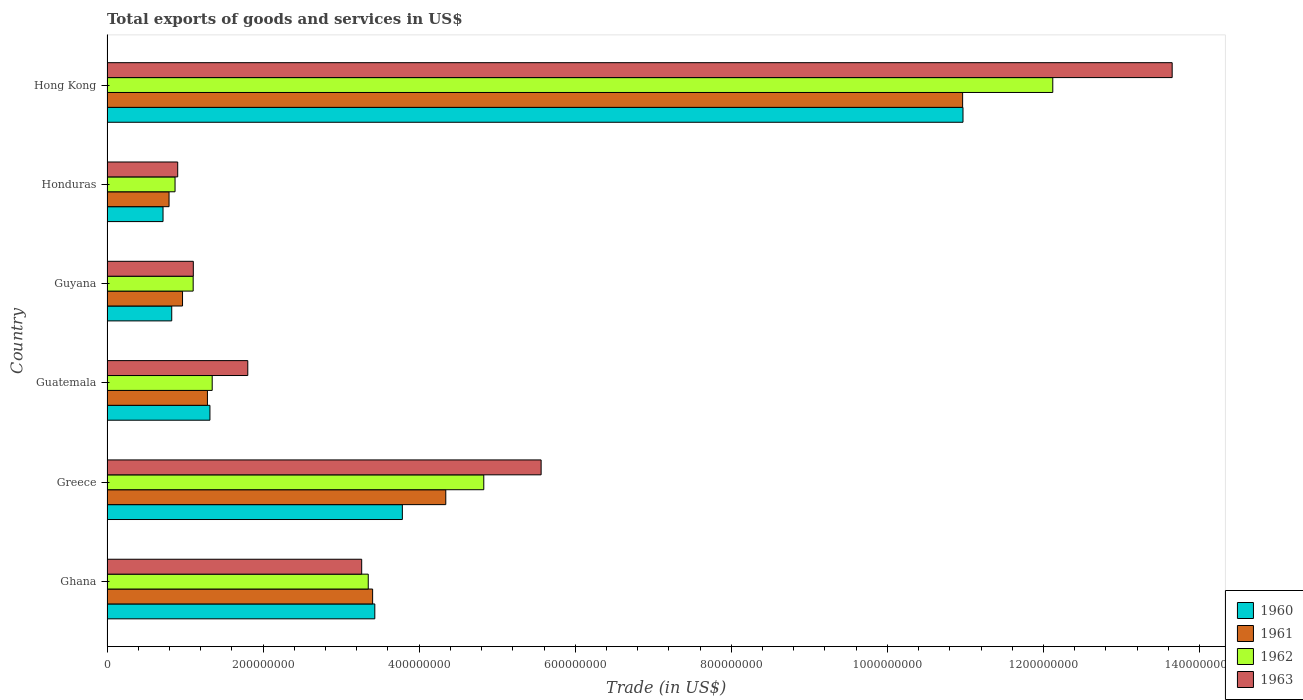How many different coloured bars are there?
Offer a terse response. 4. How many groups of bars are there?
Offer a very short reply. 6. Are the number of bars on each tick of the Y-axis equal?
Your answer should be very brief. Yes. What is the label of the 4th group of bars from the top?
Offer a terse response. Guatemala. In how many cases, is the number of bars for a given country not equal to the number of legend labels?
Give a very brief answer. 0. What is the total exports of goods and services in 1962 in Guatemala?
Keep it short and to the point. 1.35e+08. Across all countries, what is the maximum total exports of goods and services in 1962?
Make the answer very short. 1.21e+09. Across all countries, what is the minimum total exports of goods and services in 1962?
Offer a terse response. 8.72e+07. In which country was the total exports of goods and services in 1963 maximum?
Give a very brief answer. Hong Kong. In which country was the total exports of goods and services in 1961 minimum?
Provide a short and direct response. Honduras. What is the total total exports of goods and services in 1962 in the graph?
Give a very brief answer. 2.36e+09. What is the difference between the total exports of goods and services in 1961 in Greece and that in Honduras?
Provide a short and direct response. 3.55e+08. What is the difference between the total exports of goods and services in 1960 in Ghana and the total exports of goods and services in 1961 in Honduras?
Offer a terse response. 2.64e+08. What is the average total exports of goods and services in 1960 per country?
Provide a short and direct response. 3.51e+08. What is the difference between the total exports of goods and services in 1961 and total exports of goods and services in 1963 in Guatemala?
Provide a succinct answer. -5.17e+07. What is the ratio of the total exports of goods and services in 1963 in Ghana to that in Guyana?
Offer a very short reply. 2.95. What is the difference between the highest and the second highest total exports of goods and services in 1961?
Your response must be concise. 6.62e+08. What is the difference between the highest and the lowest total exports of goods and services in 1961?
Your response must be concise. 1.02e+09. In how many countries, is the total exports of goods and services in 1960 greater than the average total exports of goods and services in 1960 taken over all countries?
Provide a short and direct response. 2. Is it the case that in every country, the sum of the total exports of goods and services in 1960 and total exports of goods and services in 1963 is greater than the sum of total exports of goods and services in 1961 and total exports of goods and services in 1962?
Your answer should be compact. No. What does the 3rd bar from the top in Greece represents?
Ensure brevity in your answer.  1961. What does the 2nd bar from the bottom in Guatemala represents?
Offer a terse response. 1961. Is it the case that in every country, the sum of the total exports of goods and services in 1963 and total exports of goods and services in 1960 is greater than the total exports of goods and services in 1962?
Provide a succinct answer. Yes. Are all the bars in the graph horizontal?
Your answer should be very brief. Yes. How many countries are there in the graph?
Give a very brief answer. 6. Are the values on the major ticks of X-axis written in scientific E-notation?
Provide a succinct answer. No. Does the graph contain any zero values?
Your answer should be very brief. No. Where does the legend appear in the graph?
Your answer should be compact. Bottom right. How many legend labels are there?
Your response must be concise. 4. What is the title of the graph?
Offer a very short reply. Total exports of goods and services in US$. Does "1970" appear as one of the legend labels in the graph?
Provide a short and direct response. No. What is the label or title of the X-axis?
Offer a terse response. Trade (in US$). What is the label or title of the Y-axis?
Offer a very short reply. Country. What is the Trade (in US$) in 1960 in Ghana?
Provide a succinct answer. 3.43e+08. What is the Trade (in US$) of 1961 in Ghana?
Provide a short and direct response. 3.40e+08. What is the Trade (in US$) in 1962 in Ghana?
Keep it short and to the point. 3.35e+08. What is the Trade (in US$) in 1963 in Ghana?
Your answer should be compact. 3.26e+08. What is the Trade (in US$) of 1960 in Greece?
Your answer should be compact. 3.78e+08. What is the Trade (in US$) in 1961 in Greece?
Provide a short and direct response. 4.34e+08. What is the Trade (in US$) in 1962 in Greece?
Keep it short and to the point. 4.83e+08. What is the Trade (in US$) in 1963 in Greece?
Offer a very short reply. 5.56e+08. What is the Trade (in US$) in 1960 in Guatemala?
Your answer should be very brief. 1.32e+08. What is the Trade (in US$) in 1961 in Guatemala?
Ensure brevity in your answer.  1.29e+08. What is the Trade (in US$) of 1962 in Guatemala?
Keep it short and to the point. 1.35e+08. What is the Trade (in US$) in 1963 in Guatemala?
Keep it short and to the point. 1.80e+08. What is the Trade (in US$) in 1960 in Guyana?
Offer a very short reply. 8.29e+07. What is the Trade (in US$) in 1961 in Guyana?
Offer a very short reply. 9.68e+07. What is the Trade (in US$) of 1962 in Guyana?
Provide a succinct answer. 1.10e+08. What is the Trade (in US$) in 1963 in Guyana?
Your response must be concise. 1.11e+08. What is the Trade (in US$) in 1960 in Honduras?
Offer a very short reply. 7.18e+07. What is the Trade (in US$) of 1961 in Honduras?
Ensure brevity in your answer.  7.95e+07. What is the Trade (in US$) of 1962 in Honduras?
Offer a very short reply. 8.72e+07. What is the Trade (in US$) in 1963 in Honduras?
Ensure brevity in your answer.  9.06e+07. What is the Trade (in US$) in 1960 in Hong Kong?
Offer a terse response. 1.10e+09. What is the Trade (in US$) of 1961 in Hong Kong?
Provide a short and direct response. 1.10e+09. What is the Trade (in US$) in 1962 in Hong Kong?
Make the answer very short. 1.21e+09. What is the Trade (in US$) of 1963 in Hong Kong?
Ensure brevity in your answer.  1.36e+09. Across all countries, what is the maximum Trade (in US$) in 1960?
Keep it short and to the point. 1.10e+09. Across all countries, what is the maximum Trade (in US$) of 1961?
Keep it short and to the point. 1.10e+09. Across all countries, what is the maximum Trade (in US$) in 1962?
Provide a succinct answer. 1.21e+09. Across all countries, what is the maximum Trade (in US$) in 1963?
Provide a short and direct response. 1.36e+09. Across all countries, what is the minimum Trade (in US$) of 1960?
Offer a very short reply. 7.18e+07. Across all countries, what is the minimum Trade (in US$) in 1961?
Ensure brevity in your answer.  7.95e+07. Across all countries, what is the minimum Trade (in US$) in 1962?
Offer a terse response. 8.72e+07. Across all countries, what is the minimum Trade (in US$) of 1963?
Provide a succinct answer. 9.06e+07. What is the total Trade (in US$) in 1960 in the graph?
Make the answer very short. 2.11e+09. What is the total Trade (in US$) of 1961 in the graph?
Provide a succinct answer. 2.18e+09. What is the total Trade (in US$) of 1962 in the graph?
Offer a terse response. 2.36e+09. What is the total Trade (in US$) of 1963 in the graph?
Your answer should be compact. 2.63e+09. What is the difference between the Trade (in US$) in 1960 in Ghana and that in Greece?
Ensure brevity in your answer.  -3.53e+07. What is the difference between the Trade (in US$) of 1961 in Ghana and that in Greece?
Your response must be concise. -9.37e+07. What is the difference between the Trade (in US$) in 1962 in Ghana and that in Greece?
Provide a short and direct response. -1.48e+08. What is the difference between the Trade (in US$) in 1963 in Ghana and that in Greece?
Make the answer very short. -2.30e+08. What is the difference between the Trade (in US$) in 1960 in Ghana and that in Guatemala?
Ensure brevity in your answer.  2.11e+08. What is the difference between the Trade (in US$) of 1961 in Ghana and that in Guatemala?
Make the answer very short. 2.12e+08. What is the difference between the Trade (in US$) in 1962 in Ghana and that in Guatemala?
Give a very brief answer. 2.00e+08. What is the difference between the Trade (in US$) of 1963 in Ghana and that in Guatemala?
Ensure brevity in your answer.  1.46e+08. What is the difference between the Trade (in US$) of 1960 in Ghana and that in Guyana?
Keep it short and to the point. 2.60e+08. What is the difference between the Trade (in US$) in 1961 in Ghana and that in Guyana?
Offer a very short reply. 2.44e+08. What is the difference between the Trade (in US$) in 1962 in Ghana and that in Guyana?
Make the answer very short. 2.24e+08. What is the difference between the Trade (in US$) of 1963 in Ghana and that in Guyana?
Offer a terse response. 2.16e+08. What is the difference between the Trade (in US$) in 1960 in Ghana and that in Honduras?
Your answer should be very brief. 2.71e+08. What is the difference between the Trade (in US$) of 1961 in Ghana and that in Honduras?
Offer a very short reply. 2.61e+08. What is the difference between the Trade (in US$) of 1962 in Ghana and that in Honduras?
Offer a terse response. 2.48e+08. What is the difference between the Trade (in US$) in 1963 in Ghana and that in Honduras?
Provide a short and direct response. 2.36e+08. What is the difference between the Trade (in US$) of 1960 in Ghana and that in Hong Kong?
Provide a short and direct response. -7.54e+08. What is the difference between the Trade (in US$) in 1961 in Ghana and that in Hong Kong?
Your response must be concise. -7.56e+08. What is the difference between the Trade (in US$) of 1962 in Ghana and that in Hong Kong?
Your answer should be compact. -8.77e+08. What is the difference between the Trade (in US$) of 1963 in Ghana and that in Hong Kong?
Your answer should be compact. -1.04e+09. What is the difference between the Trade (in US$) of 1960 in Greece and that in Guatemala?
Your response must be concise. 2.47e+08. What is the difference between the Trade (in US$) in 1961 in Greece and that in Guatemala?
Ensure brevity in your answer.  3.05e+08. What is the difference between the Trade (in US$) in 1962 in Greece and that in Guatemala?
Keep it short and to the point. 3.48e+08. What is the difference between the Trade (in US$) in 1963 in Greece and that in Guatemala?
Make the answer very short. 3.76e+08. What is the difference between the Trade (in US$) in 1960 in Greece and that in Guyana?
Provide a short and direct response. 2.96e+08. What is the difference between the Trade (in US$) in 1961 in Greece and that in Guyana?
Provide a short and direct response. 3.37e+08. What is the difference between the Trade (in US$) in 1962 in Greece and that in Guyana?
Offer a terse response. 3.72e+08. What is the difference between the Trade (in US$) of 1963 in Greece and that in Guyana?
Make the answer very short. 4.46e+08. What is the difference between the Trade (in US$) in 1960 in Greece and that in Honduras?
Offer a terse response. 3.07e+08. What is the difference between the Trade (in US$) of 1961 in Greece and that in Honduras?
Provide a succinct answer. 3.55e+08. What is the difference between the Trade (in US$) of 1962 in Greece and that in Honduras?
Your answer should be compact. 3.96e+08. What is the difference between the Trade (in US$) in 1963 in Greece and that in Honduras?
Your response must be concise. 4.66e+08. What is the difference between the Trade (in US$) in 1960 in Greece and that in Hong Kong?
Your answer should be compact. -7.18e+08. What is the difference between the Trade (in US$) in 1961 in Greece and that in Hong Kong?
Provide a short and direct response. -6.62e+08. What is the difference between the Trade (in US$) in 1962 in Greece and that in Hong Kong?
Provide a succinct answer. -7.29e+08. What is the difference between the Trade (in US$) of 1963 in Greece and that in Hong Kong?
Your answer should be very brief. -8.09e+08. What is the difference between the Trade (in US$) of 1960 in Guatemala and that in Guyana?
Keep it short and to the point. 4.90e+07. What is the difference between the Trade (in US$) in 1961 in Guatemala and that in Guyana?
Make the answer very short. 3.19e+07. What is the difference between the Trade (in US$) of 1962 in Guatemala and that in Guyana?
Your response must be concise. 2.44e+07. What is the difference between the Trade (in US$) in 1963 in Guatemala and that in Guyana?
Offer a terse response. 6.98e+07. What is the difference between the Trade (in US$) in 1960 in Guatemala and that in Honduras?
Make the answer very short. 6.01e+07. What is the difference between the Trade (in US$) of 1961 in Guatemala and that in Honduras?
Offer a terse response. 4.92e+07. What is the difference between the Trade (in US$) in 1962 in Guatemala and that in Honduras?
Provide a short and direct response. 4.76e+07. What is the difference between the Trade (in US$) of 1963 in Guatemala and that in Honduras?
Your answer should be very brief. 8.98e+07. What is the difference between the Trade (in US$) of 1960 in Guatemala and that in Hong Kong?
Your response must be concise. -9.65e+08. What is the difference between the Trade (in US$) in 1961 in Guatemala and that in Hong Kong?
Keep it short and to the point. -9.68e+08. What is the difference between the Trade (in US$) of 1962 in Guatemala and that in Hong Kong?
Offer a terse response. -1.08e+09. What is the difference between the Trade (in US$) of 1963 in Guatemala and that in Hong Kong?
Offer a very short reply. -1.18e+09. What is the difference between the Trade (in US$) of 1960 in Guyana and that in Honduras?
Make the answer very short. 1.11e+07. What is the difference between the Trade (in US$) of 1961 in Guyana and that in Honduras?
Make the answer very short. 1.73e+07. What is the difference between the Trade (in US$) in 1962 in Guyana and that in Honduras?
Your answer should be compact. 2.32e+07. What is the difference between the Trade (in US$) in 1963 in Guyana and that in Honduras?
Your answer should be very brief. 2.00e+07. What is the difference between the Trade (in US$) of 1960 in Guyana and that in Hong Kong?
Your answer should be compact. -1.01e+09. What is the difference between the Trade (in US$) in 1961 in Guyana and that in Hong Kong?
Your response must be concise. -1.00e+09. What is the difference between the Trade (in US$) of 1962 in Guyana and that in Hong Kong?
Ensure brevity in your answer.  -1.10e+09. What is the difference between the Trade (in US$) in 1963 in Guyana and that in Hong Kong?
Your answer should be very brief. -1.25e+09. What is the difference between the Trade (in US$) of 1960 in Honduras and that in Hong Kong?
Keep it short and to the point. -1.03e+09. What is the difference between the Trade (in US$) in 1961 in Honduras and that in Hong Kong?
Your response must be concise. -1.02e+09. What is the difference between the Trade (in US$) in 1962 in Honduras and that in Hong Kong?
Ensure brevity in your answer.  -1.12e+09. What is the difference between the Trade (in US$) of 1963 in Honduras and that in Hong Kong?
Offer a terse response. -1.27e+09. What is the difference between the Trade (in US$) of 1960 in Ghana and the Trade (in US$) of 1961 in Greece?
Your answer should be very brief. -9.09e+07. What is the difference between the Trade (in US$) of 1960 in Ghana and the Trade (in US$) of 1962 in Greece?
Your answer should be very brief. -1.40e+08. What is the difference between the Trade (in US$) in 1960 in Ghana and the Trade (in US$) in 1963 in Greece?
Ensure brevity in your answer.  -2.13e+08. What is the difference between the Trade (in US$) of 1961 in Ghana and the Trade (in US$) of 1962 in Greece?
Make the answer very short. -1.42e+08. What is the difference between the Trade (in US$) in 1961 in Ghana and the Trade (in US$) in 1963 in Greece?
Offer a terse response. -2.16e+08. What is the difference between the Trade (in US$) of 1962 in Ghana and the Trade (in US$) of 1963 in Greece?
Your response must be concise. -2.22e+08. What is the difference between the Trade (in US$) of 1960 in Ghana and the Trade (in US$) of 1961 in Guatemala?
Make the answer very short. 2.14e+08. What is the difference between the Trade (in US$) of 1960 in Ghana and the Trade (in US$) of 1962 in Guatemala?
Provide a short and direct response. 2.08e+08. What is the difference between the Trade (in US$) in 1960 in Ghana and the Trade (in US$) in 1963 in Guatemala?
Offer a very short reply. 1.63e+08. What is the difference between the Trade (in US$) in 1961 in Ghana and the Trade (in US$) in 1962 in Guatemala?
Make the answer very short. 2.06e+08. What is the difference between the Trade (in US$) in 1961 in Ghana and the Trade (in US$) in 1963 in Guatemala?
Keep it short and to the point. 1.60e+08. What is the difference between the Trade (in US$) in 1962 in Ghana and the Trade (in US$) in 1963 in Guatemala?
Provide a succinct answer. 1.54e+08. What is the difference between the Trade (in US$) of 1960 in Ghana and the Trade (in US$) of 1961 in Guyana?
Your answer should be compact. 2.46e+08. What is the difference between the Trade (in US$) in 1960 in Ghana and the Trade (in US$) in 1962 in Guyana?
Provide a short and direct response. 2.33e+08. What is the difference between the Trade (in US$) in 1960 in Ghana and the Trade (in US$) in 1963 in Guyana?
Offer a terse response. 2.33e+08. What is the difference between the Trade (in US$) in 1961 in Ghana and the Trade (in US$) in 1962 in Guyana?
Keep it short and to the point. 2.30e+08. What is the difference between the Trade (in US$) of 1961 in Ghana and the Trade (in US$) of 1963 in Guyana?
Offer a very short reply. 2.30e+08. What is the difference between the Trade (in US$) of 1962 in Ghana and the Trade (in US$) of 1963 in Guyana?
Provide a succinct answer. 2.24e+08. What is the difference between the Trade (in US$) of 1960 in Ghana and the Trade (in US$) of 1961 in Honduras?
Offer a very short reply. 2.64e+08. What is the difference between the Trade (in US$) of 1960 in Ghana and the Trade (in US$) of 1962 in Honduras?
Offer a very short reply. 2.56e+08. What is the difference between the Trade (in US$) of 1960 in Ghana and the Trade (in US$) of 1963 in Honduras?
Your response must be concise. 2.53e+08. What is the difference between the Trade (in US$) in 1961 in Ghana and the Trade (in US$) in 1962 in Honduras?
Your response must be concise. 2.53e+08. What is the difference between the Trade (in US$) in 1961 in Ghana and the Trade (in US$) in 1963 in Honduras?
Your answer should be very brief. 2.50e+08. What is the difference between the Trade (in US$) of 1962 in Ghana and the Trade (in US$) of 1963 in Honduras?
Give a very brief answer. 2.44e+08. What is the difference between the Trade (in US$) of 1960 in Ghana and the Trade (in US$) of 1961 in Hong Kong?
Provide a succinct answer. -7.53e+08. What is the difference between the Trade (in US$) in 1960 in Ghana and the Trade (in US$) in 1962 in Hong Kong?
Provide a short and direct response. -8.69e+08. What is the difference between the Trade (in US$) of 1960 in Ghana and the Trade (in US$) of 1963 in Hong Kong?
Provide a succinct answer. -1.02e+09. What is the difference between the Trade (in US$) of 1961 in Ghana and the Trade (in US$) of 1962 in Hong Kong?
Your response must be concise. -8.72e+08. What is the difference between the Trade (in US$) of 1961 in Ghana and the Trade (in US$) of 1963 in Hong Kong?
Keep it short and to the point. -1.02e+09. What is the difference between the Trade (in US$) in 1962 in Ghana and the Trade (in US$) in 1963 in Hong Kong?
Ensure brevity in your answer.  -1.03e+09. What is the difference between the Trade (in US$) of 1960 in Greece and the Trade (in US$) of 1961 in Guatemala?
Provide a short and direct response. 2.50e+08. What is the difference between the Trade (in US$) in 1960 in Greece and the Trade (in US$) in 1962 in Guatemala?
Your answer should be very brief. 2.44e+08. What is the difference between the Trade (in US$) in 1960 in Greece and the Trade (in US$) in 1963 in Guatemala?
Your answer should be compact. 1.98e+08. What is the difference between the Trade (in US$) in 1961 in Greece and the Trade (in US$) in 1962 in Guatemala?
Keep it short and to the point. 2.99e+08. What is the difference between the Trade (in US$) of 1961 in Greece and the Trade (in US$) of 1963 in Guatemala?
Offer a very short reply. 2.54e+08. What is the difference between the Trade (in US$) in 1962 in Greece and the Trade (in US$) in 1963 in Guatemala?
Ensure brevity in your answer.  3.02e+08. What is the difference between the Trade (in US$) in 1960 in Greece and the Trade (in US$) in 1961 in Guyana?
Your answer should be compact. 2.82e+08. What is the difference between the Trade (in US$) of 1960 in Greece and the Trade (in US$) of 1962 in Guyana?
Give a very brief answer. 2.68e+08. What is the difference between the Trade (in US$) in 1960 in Greece and the Trade (in US$) in 1963 in Guyana?
Offer a terse response. 2.68e+08. What is the difference between the Trade (in US$) of 1961 in Greece and the Trade (in US$) of 1962 in Guyana?
Provide a succinct answer. 3.24e+08. What is the difference between the Trade (in US$) in 1961 in Greece and the Trade (in US$) in 1963 in Guyana?
Keep it short and to the point. 3.24e+08. What is the difference between the Trade (in US$) of 1962 in Greece and the Trade (in US$) of 1963 in Guyana?
Offer a very short reply. 3.72e+08. What is the difference between the Trade (in US$) in 1960 in Greece and the Trade (in US$) in 1961 in Honduras?
Keep it short and to the point. 2.99e+08. What is the difference between the Trade (in US$) of 1960 in Greece and the Trade (in US$) of 1962 in Honduras?
Keep it short and to the point. 2.91e+08. What is the difference between the Trade (in US$) in 1960 in Greece and the Trade (in US$) in 1963 in Honduras?
Make the answer very short. 2.88e+08. What is the difference between the Trade (in US$) of 1961 in Greece and the Trade (in US$) of 1962 in Honduras?
Make the answer very short. 3.47e+08. What is the difference between the Trade (in US$) in 1961 in Greece and the Trade (in US$) in 1963 in Honduras?
Offer a very short reply. 3.44e+08. What is the difference between the Trade (in US$) of 1962 in Greece and the Trade (in US$) of 1963 in Honduras?
Make the answer very short. 3.92e+08. What is the difference between the Trade (in US$) of 1960 in Greece and the Trade (in US$) of 1961 in Hong Kong?
Your answer should be compact. -7.18e+08. What is the difference between the Trade (in US$) in 1960 in Greece and the Trade (in US$) in 1962 in Hong Kong?
Provide a succinct answer. -8.33e+08. What is the difference between the Trade (in US$) of 1960 in Greece and the Trade (in US$) of 1963 in Hong Kong?
Your response must be concise. -9.86e+08. What is the difference between the Trade (in US$) in 1961 in Greece and the Trade (in US$) in 1962 in Hong Kong?
Offer a very short reply. -7.78e+08. What is the difference between the Trade (in US$) of 1961 in Greece and the Trade (in US$) of 1963 in Hong Kong?
Ensure brevity in your answer.  -9.31e+08. What is the difference between the Trade (in US$) of 1962 in Greece and the Trade (in US$) of 1963 in Hong Kong?
Give a very brief answer. -8.82e+08. What is the difference between the Trade (in US$) in 1960 in Guatemala and the Trade (in US$) in 1961 in Guyana?
Make the answer very short. 3.51e+07. What is the difference between the Trade (in US$) in 1960 in Guatemala and the Trade (in US$) in 1962 in Guyana?
Ensure brevity in your answer.  2.15e+07. What is the difference between the Trade (in US$) of 1960 in Guatemala and the Trade (in US$) of 1963 in Guyana?
Offer a terse response. 2.13e+07. What is the difference between the Trade (in US$) of 1961 in Guatemala and the Trade (in US$) of 1962 in Guyana?
Keep it short and to the point. 1.83e+07. What is the difference between the Trade (in US$) of 1961 in Guatemala and the Trade (in US$) of 1963 in Guyana?
Offer a terse response. 1.81e+07. What is the difference between the Trade (in US$) of 1962 in Guatemala and the Trade (in US$) of 1963 in Guyana?
Your answer should be very brief. 2.42e+07. What is the difference between the Trade (in US$) in 1960 in Guatemala and the Trade (in US$) in 1961 in Honduras?
Provide a succinct answer. 5.24e+07. What is the difference between the Trade (in US$) of 1960 in Guatemala and the Trade (in US$) of 1962 in Honduras?
Provide a succinct answer. 4.47e+07. What is the difference between the Trade (in US$) in 1960 in Guatemala and the Trade (in US$) in 1963 in Honduras?
Provide a succinct answer. 4.13e+07. What is the difference between the Trade (in US$) of 1961 in Guatemala and the Trade (in US$) of 1962 in Honduras?
Your answer should be compact. 4.15e+07. What is the difference between the Trade (in US$) in 1961 in Guatemala and the Trade (in US$) in 1963 in Honduras?
Your response must be concise. 3.81e+07. What is the difference between the Trade (in US$) in 1962 in Guatemala and the Trade (in US$) in 1963 in Honduras?
Ensure brevity in your answer.  4.42e+07. What is the difference between the Trade (in US$) in 1960 in Guatemala and the Trade (in US$) in 1961 in Hong Kong?
Your answer should be very brief. -9.65e+08. What is the difference between the Trade (in US$) in 1960 in Guatemala and the Trade (in US$) in 1962 in Hong Kong?
Make the answer very short. -1.08e+09. What is the difference between the Trade (in US$) of 1960 in Guatemala and the Trade (in US$) of 1963 in Hong Kong?
Make the answer very short. -1.23e+09. What is the difference between the Trade (in US$) in 1961 in Guatemala and the Trade (in US$) in 1962 in Hong Kong?
Your answer should be very brief. -1.08e+09. What is the difference between the Trade (in US$) in 1961 in Guatemala and the Trade (in US$) in 1963 in Hong Kong?
Provide a succinct answer. -1.24e+09. What is the difference between the Trade (in US$) of 1962 in Guatemala and the Trade (in US$) of 1963 in Hong Kong?
Your answer should be very brief. -1.23e+09. What is the difference between the Trade (in US$) of 1960 in Guyana and the Trade (in US$) of 1961 in Honduras?
Your response must be concise. 3.45e+06. What is the difference between the Trade (in US$) in 1960 in Guyana and the Trade (in US$) in 1962 in Honduras?
Keep it short and to the point. -4.25e+06. What is the difference between the Trade (in US$) in 1960 in Guyana and the Trade (in US$) in 1963 in Honduras?
Give a very brief answer. -7.65e+06. What is the difference between the Trade (in US$) of 1961 in Guyana and the Trade (in US$) of 1962 in Honduras?
Offer a terse response. 9.57e+06. What is the difference between the Trade (in US$) in 1961 in Guyana and the Trade (in US$) in 1963 in Honduras?
Provide a short and direct response. 6.17e+06. What is the difference between the Trade (in US$) of 1962 in Guyana and the Trade (in US$) of 1963 in Honduras?
Make the answer very short. 1.98e+07. What is the difference between the Trade (in US$) of 1960 in Guyana and the Trade (in US$) of 1961 in Hong Kong?
Offer a terse response. -1.01e+09. What is the difference between the Trade (in US$) in 1960 in Guyana and the Trade (in US$) in 1962 in Hong Kong?
Your answer should be very brief. -1.13e+09. What is the difference between the Trade (in US$) of 1960 in Guyana and the Trade (in US$) of 1963 in Hong Kong?
Keep it short and to the point. -1.28e+09. What is the difference between the Trade (in US$) in 1961 in Guyana and the Trade (in US$) in 1962 in Hong Kong?
Offer a terse response. -1.12e+09. What is the difference between the Trade (in US$) in 1961 in Guyana and the Trade (in US$) in 1963 in Hong Kong?
Give a very brief answer. -1.27e+09. What is the difference between the Trade (in US$) in 1962 in Guyana and the Trade (in US$) in 1963 in Hong Kong?
Provide a succinct answer. -1.25e+09. What is the difference between the Trade (in US$) of 1960 in Honduras and the Trade (in US$) of 1961 in Hong Kong?
Ensure brevity in your answer.  -1.02e+09. What is the difference between the Trade (in US$) in 1960 in Honduras and the Trade (in US$) in 1962 in Hong Kong?
Ensure brevity in your answer.  -1.14e+09. What is the difference between the Trade (in US$) of 1960 in Honduras and the Trade (in US$) of 1963 in Hong Kong?
Provide a succinct answer. -1.29e+09. What is the difference between the Trade (in US$) in 1961 in Honduras and the Trade (in US$) in 1962 in Hong Kong?
Provide a succinct answer. -1.13e+09. What is the difference between the Trade (in US$) in 1961 in Honduras and the Trade (in US$) in 1963 in Hong Kong?
Your answer should be compact. -1.29e+09. What is the difference between the Trade (in US$) of 1962 in Honduras and the Trade (in US$) of 1963 in Hong Kong?
Make the answer very short. -1.28e+09. What is the average Trade (in US$) in 1960 per country?
Keep it short and to the point. 3.51e+08. What is the average Trade (in US$) in 1961 per country?
Keep it short and to the point. 3.63e+08. What is the average Trade (in US$) in 1962 per country?
Your answer should be very brief. 3.94e+08. What is the average Trade (in US$) in 1963 per country?
Offer a very short reply. 4.38e+08. What is the difference between the Trade (in US$) in 1960 and Trade (in US$) in 1961 in Ghana?
Give a very brief answer. 2.80e+06. What is the difference between the Trade (in US$) in 1960 and Trade (in US$) in 1962 in Ghana?
Provide a short and direct response. 8.40e+06. What is the difference between the Trade (in US$) in 1960 and Trade (in US$) in 1963 in Ghana?
Provide a short and direct response. 1.68e+07. What is the difference between the Trade (in US$) of 1961 and Trade (in US$) of 1962 in Ghana?
Your answer should be very brief. 5.60e+06. What is the difference between the Trade (in US$) in 1961 and Trade (in US$) in 1963 in Ghana?
Give a very brief answer. 1.40e+07. What is the difference between the Trade (in US$) in 1962 and Trade (in US$) in 1963 in Ghana?
Offer a terse response. 8.40e+06. What is the difference between the Trade (in US$) of 1960 and Trade (in US$) of 1961 in Greece?
Provide a short and direct response. -5.56e+07. What is the difference between the Trade (in US$) in 1960 and Trade (in US$) in 1962 in Greece?
Your answer should be very brief. -1.04e+08. What is the difference between the Trade (in US$) in 1960 and Trade (in US$) in 1963 in Greece?
Your response must be concise. -1.78e+08. What is the difference between the Trade (in US$) in 1961 and Trade (in US$) in 1962 in Greece?
Your response must be concise. -4.87e+07. What is the difference between the Trade (in US$) in 1961 and Trade (in US$) in 1963 in Greece?
Your answer should be compact. -1.22e+08. What is the difference between the Trade (in US$) in 1962 and Trade (in US$) in 1963 in Greece?
Ensure brevity in your answer.  -7.35e+07. What is the difference between the Trade (in US$) of 1960 and Trade (in US$) of 1961 in Guatemala?
Keep it short and to the point. 3.20e+06. What is the difference between the Trade (in US$) in 1960 and Trade (in US$) in 1962 in Guatemala?
Keep it short and to the point. -2.90e+06. What is the difference between the Trade (in US$) in 1960 and Trade (in US$) in 1963 in Guatemala?
Offer a very short reply. -4.85e+07. What is the difference between the Trade (in US$) of 1961 and Trade (in US$) of 1962 in Guatemala?
Provide a short and direct response. -6.10e+06. What is the difference between the Trade (in US$) of 1961 and Trade (in US$) of 1963 in Guatemala?
Give a very brief answer. -5.17e+07. What is the difference between the Trade (in US$) of 1962 and Trade (in US$) of 1963 in Guatemala?
Ensure brevity in your answer.  -4.56e+07. What is the difference between the Trade (in US$) in 1960 and Trade (in US$) in 1961 in Guyana?
Give a very brief answer. -1.38e+07. What is the difference between the Trade (in US$) in 1960 and Trade (in US$) in 1962 in Guyana?
Provide a short and direct response. -2.75e+07. What is the difference between the Trade (in US$) in 1960 and Trade (in US$) in 1963 in Guyana?
Make the answer very short. -2.76e+07. What is the difference between the Trade (in US$) in 1961 and Trade (in US$) in 1962 in Guyana?
Provide a succinct answer. -1.36e+07. What is the difference between the Trade (in US$) in 1961 and Trade (in US$) in 1963 in Guyana?
Your response must be concise. -1.38e+07. What is the difference between the Trade (in US$) of 1962 and Trade (in US$) of 1963 in Guyana?
Provide a short and direct response. -1.75e+05. What is the difference between the Trade (in US$) of 1960 and Trade (in US$) of 1961 in Honduras?
Your answer should be very brief. -7.70e+06. What is the difference between the Trade (in US$) in 1960 and Trade (in US$) in 1962 in Honduras?
Offer a very short reply. -1.54e+07. What is the difference between the Trade (in US$) in 1960 and Trade (in US$) in 1963 in Honduras?
Provide a short and direct response. -1.88e+07. What is the difference between the Trade (in US$) in 1961 and Trade (in US$) in 1962 in Honduras?
Your answer should be very brief. -7.70e+06. What is the difference between the Trade (in US$) in 1961 and Trade (in US$) in 1963 in Honduras?
Your response must be concise. -1.11e+07. What is the difference between the Trade (in US$) in 1962 and Trade (in US$) in 1963 in Honduras?
Give a very brief answer. -3.40e+06. What is the difference between the Trade (in US$) of 1960 and Trade (in US$) of 1961 in Hong Kong?
Offer a terse response. 4.96e+05. What is the difference between the Trade (in US$) of 1960 and Trade (in US$) of 1962 in Hong Kong?
Your answer should be very brief. -1.15e+08. What is the difference between the Trade (in US$) in 1960 and Trade (in US$) in 1963 in Hong Kong?
Your answer should be compact. -2.68e+08. What is the difference between the Trade (in US$) in 1961 and Trade (in US$) in 1962 in Hong Kong?
Your response must be concise. -1.16e+08. What is the difference between the Trade (in US$) in 1961 and Trade (in US$) in 1963 in Hong Kong?
Your answer should be very brief. -2.69e+08. What is the difference between the Trade (in US$) of 1962 and Trade (in US$) of 1963 in Hong Kong?
Provide a short and direct response. -1.53e+08. What is the ratio of the Trade (in US$) in 1960 in Ghana to that in Greece?
Your answer should be very brief. 0.91. What is the ratio of the Trade (in US$) in 1961 in Ghana to that in Greece?
Make the answer very short. 0.78. What is the ratio of the Trade (in US$) of 1962 in Ghana to that in Greece?
Give a very brief answer. 0.69. What is the ratio of the Trade (in US$) of 1963 in Ghana to that in Greece?
Offer a very short reply. 0.59. What is the ratio of the Trade (in US$) of 1960 in Ghana to that in Guatemala?
Offer a terse response. 2.6. What is the ratio of the Trade (in US$) in 1961 in Ghana to that in Guatemala?
Keep it short and to the point. 2.64. What is the ratio of the Trade (in US$) in 1962 in Ghana to that in Guatemala?
Make the answer very short. 2.48. What is the ratio of the Trade (in US$) in 1963 in Ghana to that in Guatemala?
Offer a terse response. 1.81. What is the ratio of the Trade (in US$) of 1960 in Ghana to that in Guyana?
Your answer should be compact. 4.14. What is the ratio of the Trade (in US$) of 1961 in Ghana to that in Guyana?
Provide a short and direct response. 3.52. What is the ratio of the Trade (in US$) in 1962 in Ghana to that in Guyana?
Ensure brevity in your answer.  3.03. What is the ratio of the Trade (in US$) of 1963 in Ghana to that in Guyana?
Provide a succinct answer. 2.95. What is the ratio of the Trade (in US$) of 1960 in Ghana to that in Honduras?
Offer a terse response. 4.78. What is the ratio of the Trade (in US$) in 1961 in Ghana to that in Honduras?
Keep it short and to the point. 4.28. What is the ratio of the Trade (in US$) in 1962 in Ghana to that in Honduras?
Keep it short and to the point. 3.84. What is the ratio of the Trade (in US$) in 1963 in Ghana to that in Honduras?
Your response must be concise. 3.6. What is the ratio of the Trade (in US$) of 1960 in Ghana to that in Hong Kong?
Offer a very short reply. 0.31. What is the ratio of the Trade (in US$) in 1961 in Ghana to that in Hong Kong?
Your answer should be compact. 0.31. What is the ratio of the Trade (in US$) of 1962 in Ghana to that in Hong Kong?
Offer a very short reply. 0.28. What is the ratio of the Trade (in US$) of 1963 in Ghana to that in Hong Kong?
Offer a terse response. 0.24. What is the ratio of the Trade (in US$) of 1960 in Greece to that in Guatemala?
Make the answer very short. 2.87. What is the ratio of the Trade (in US$) of 1961 in Greece to that in Guatemala?
Your answer should be compact. 3.37. What is the ratio of the Trade (in US$) of 1962 in Greece to that in Guatemala?
Your answer should be compact. 3.58. What is the ratio of the Trade (in US$) in 1963 in Greece to that in Guatemala?
Ensure brevity in your answer.  3.08. What is the ratio of the Trade (in US$) of 1960 in Greece to that in Guyana?
Provide a short and direct response. 4.56. What is the ratio of the Trade (in US$) in 1961 in Greece to that in Guyana?
Offer a very short reply. 4.49. What is the ratio of the Trade (in US$) in 1962 in Greece to that in Guyana?
Provide a succinct answer. 4.37. What is the ratio of the Trade (in US$) in 1963 in Greece to that in Guyana?
Provide a short and direct response. 5.03. What is the ratio of the Trade (in US$) of 1960 in Greece to that in Honduras?
Your response must be concise. 5.27. What is the ratio of the Trade (in US$) in 1961 in Greece to that in Honduras?
Make the answer very short. 5.46. What is the ratio of the Trade (in US$) in 1962 in Greece to that in Honduras?
Your answer should be compact. 5.54. What is the ratio of the Trade (in US$) of 1963 in Greece to that in Honduras?
Give a very brief answer. 6.14. What is the ratio of the Trade (in US$) in 1960 in Greece to that in Hong Kong?
Give a very brief answer. 0.34. What is the ratio of the Trade (in US$) of 1961 in Greece to that in Hong Kong?
Your answer should be very brief. 0.4. What is the ratio of the Trade (in US$) in 1962 in Greece to that in Hong Kong?
Offer a terse response. 0.4. What is the ratio of the Trade (in US$) in 1963 in Greece to that in Hong Kong?
Offer a very short reply. 0.41. What is the ratio of the Trade (in US$) of 1960 in Guatemala to that in Guyana?
Your answer should be very brief. 1.59. What is the ratio of the Trade (in US$) in 1961 in Guatemala to that in Guyana?
Your answer should be very brief. 1.33. What is the ratio of the Trade (in US$) of 1962 in Guatemala to that in Guyana?
Make the answer very short. 1.22. What is the ratio of the Trade (in US$) in 1963 in Guatemala to that in Guyana?
Offer a very short reply. 1.63. What is the ratio of the Trade (in US$) in 1960 in Guatemala to that in Honduras?
Your answer should be very brief. 1.84. What is the ratio of the Trade (in US$) in 1961 in Guatemala to that in Honduras?
Your response must be concise. 1.62. What is the ratio of the Trade (in US$) in 1962 in Guatemala to that in Honduras?
Make the answer very short. 1.55. What is the ratio of the Trade (in US$) of 1963 in Guatemala to that in Honduras?
Your response must be concise. 1.99. What is the ratio of the Trade (in US$) in 1960 in Guatemala to that in Hong Kong?
Offer a terse response. 0.12. What is the ratio of the Trade (in US$) of 1961 in Guatemala to that in Hong Kong?
Make the answer very short. 0.12. What is the ratio of the Trade (in US$) of 1962 in Guatemala to that in Hong Kong?
Keep it short and to the point. 0.11. What is the ratio of the Trade (in US$) of 1963 in Guatemala to that in Hong Kong?
Your response must be concise. 0.13. What is the ratio of the Trade (in US$) in 1960 in Guyana to that in Honduras?
Keep it short and to the point. 1.16. What is the ratio of the Trade (in US$) in 1961 in Guyana to that in Honduras?
Ensure brevity in your answer.  1.22. What is the ratio of the Trade (in US$) in 1962 in Guyana to that in Honduras?
Ensure brevity in your answer.  1.27. What is the ratio of the Trade (in US$) in 1963 in Guyana to that in Honduras?
Give a very brief answer. 1.22. What is the ratio of the Trade (in US$) in 1960 in Guyana to that in Hong Kong?
Your response must be concise. 0.08. What is the ratio of the Trade (in US$) of 1961 in Guyana to that in Hong Kong?
Offer a very short reply. 0.09. What is the ratio of the Trade (in US$) in 1962 in Guyana to that in Hong Kong?
Provide a short and direct response. 0.09. What is the ratio of the Trade (in US$) in 1963 in Guyana to that in Hong Kong?
Provide a succinct answer. 0.08. What is the ratio of the Trade (in US$) in 1960 in Honduras to that in Hong Kong?
Offer a very short reply. 0.07. What is the ratio of the Trade (in US$) of 1961 in Honduras to that in Hong Kong?
Your response must be concise. 0.07. What is the ratio of the Trade (in US$) of 1962 in Honduras to that in Hong Kong?
Your response must be concise. 0.07. What is the ratio of the Trade (in US$) of 1963 in Honduras to that in Hong Kong?
Your answer should be very brief. 0.07. What is the difference between the highest and the second highest Trade (in US$) in 1960?
Keep it short and to the point. 7.18e+08. What is the difference between the highest and the second highest Trade (in US$) of 1961?
Keep it short and to the point. 6.62e+08. What is the difference between the highest and the second highest Trade (in US$) of 1962?
Your answer should be very brief. 7.29e+08. What is the difference between the highest and the second highest Trade (in US$) of 1963?
Ensure brevity in your answer.  8.09e+08. What is the difference between the highest and the lowest Trade (in US$) in 1960?
Your answer should be very brief. 1.03e+09. What is the difference between the highest and the lowest Trade (in US$) of 1961?
Provide a short and direct response. 1.02e+09. What is the difference between the highest and the lowest Trade (in US$) of 1962?
Your response must be concise. 1.12e+09. What is the difference between the highest and the lowest Trade (in US$) in 1963?
Your answer should be very brief. 1.27e+09. 